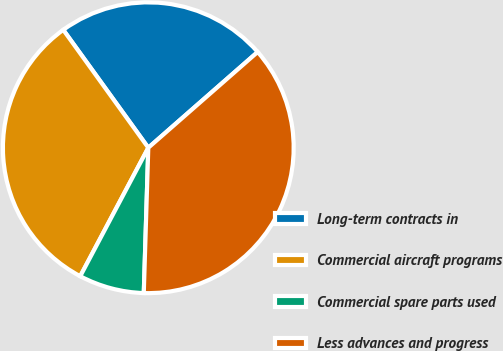<chart> <loc_0><loc_0><loc_500><loc_500><pie_chart><fcel>Long-term contracts in<fcel>Commercial aircraft programs<fcel>Commercial spare parts used<fcel>Less advances and progress<nl><fcel>23.5%<fcel>32.3%<fcel>7.26%<fcel>36.94%<nl></chart> 